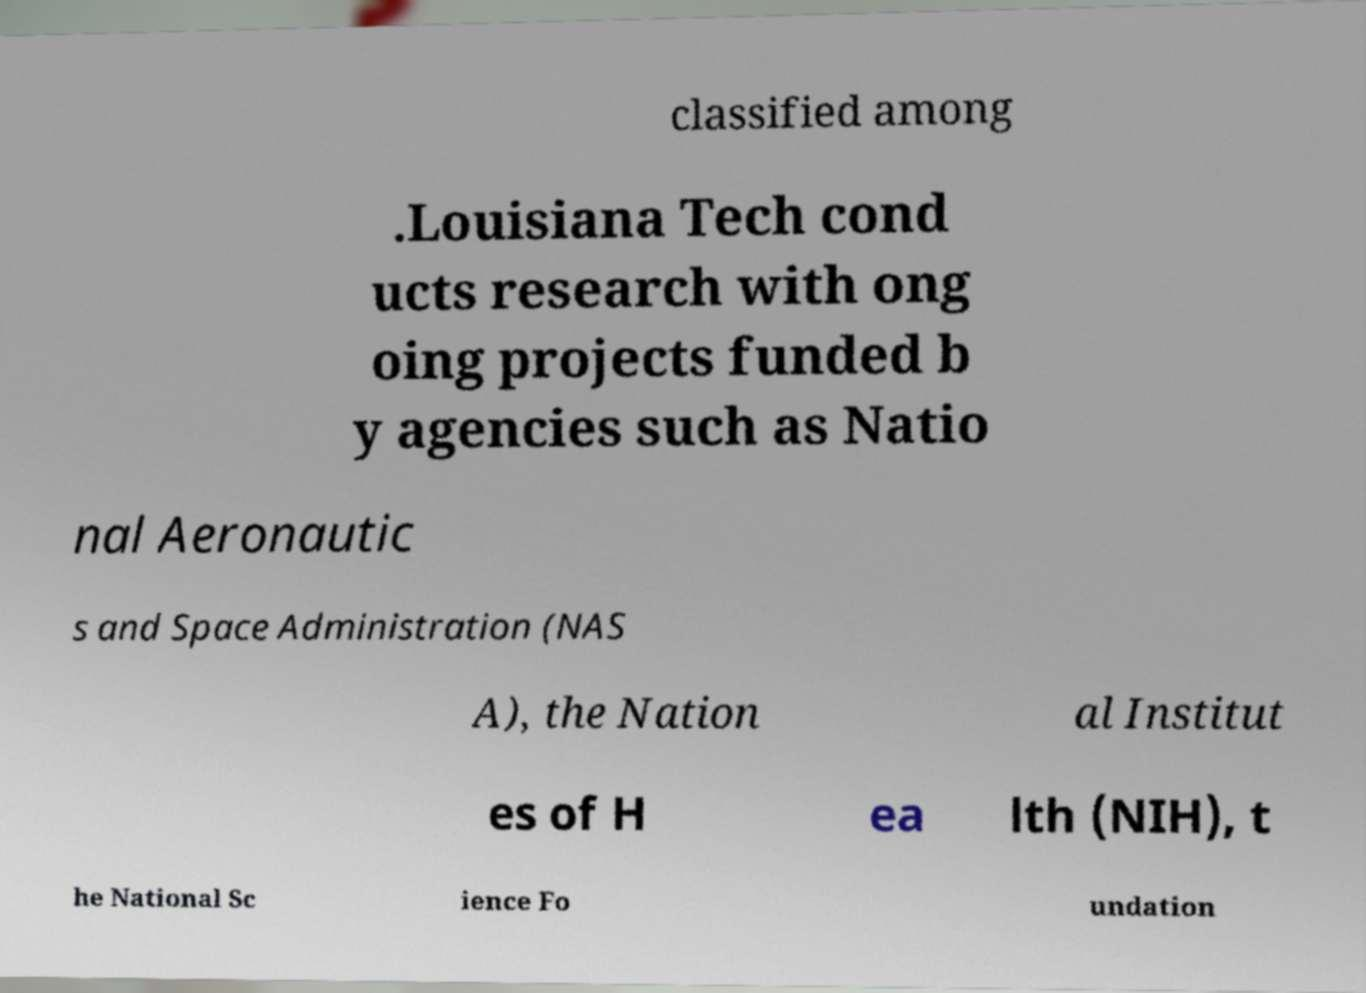What messages or text are displayed in this image? I need them in a readable, typed format. classified among .Louisiana Tech cond ucts research with ong oing projects funded b y agencies such as Natio nal Aeronautic s and Space Administration (NAS A), the Nation al Institut es of H ea lth (NIH), t he National Sc ience Fo undation 